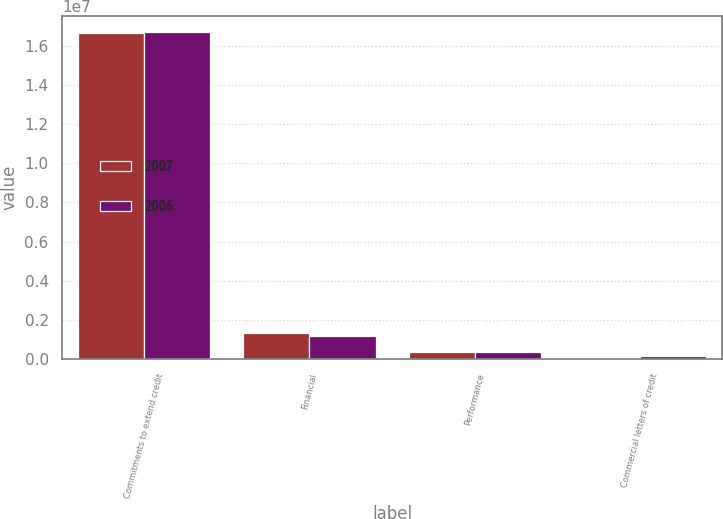Convert chart to OTSL. <chart><loc_0><loc_0><loc_500><loc_500><stacked_bar_chart><ecel><fcel>Commitments to extend credit<fcel>Financial<fcel>Performance<fcel>Commercial letters of credit<nl><fcel>2007<fcel>1.66481e+07<fcel>1.3173e+06<fcel>351150<fcel>49346<nl><fcel>2006<fcel>1.67147e+07<fcel>1.1572e+06<fcel>330056<fcel>132615<nl></chart> 